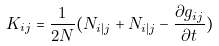Convert formula to latex. <formula><loc_0><loc_0><loc_500><loc_500>K _ { i j } = \frac { 1 } { 2 N } ( N _ { i | j } + N _ { i | j } - \frac { \partial g _ { i j } } { \partial t } )</formula> 